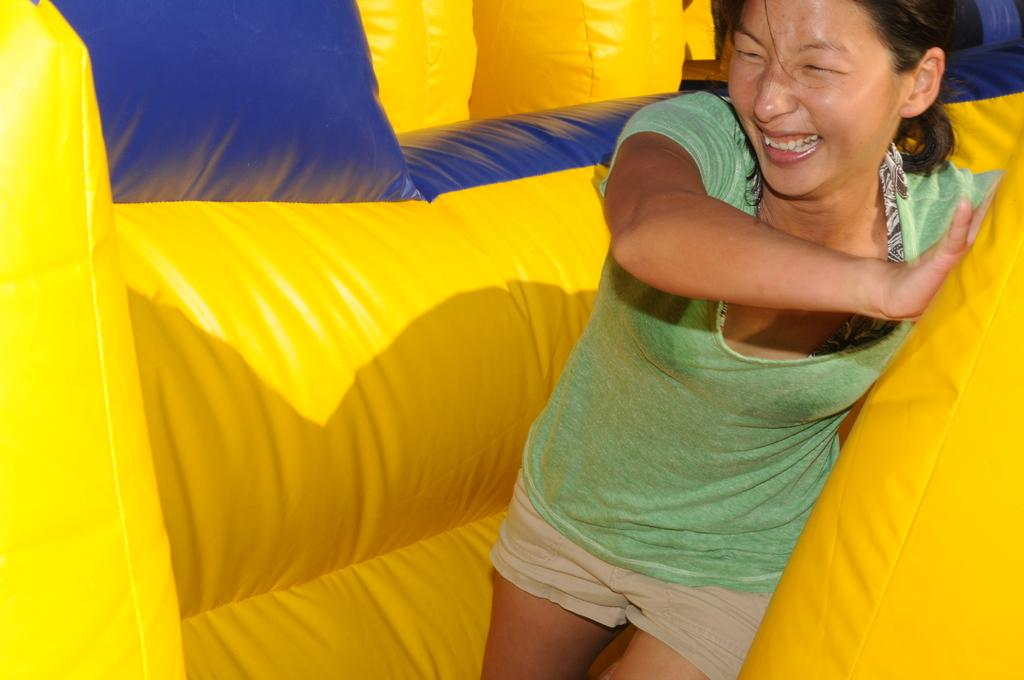Who is present in the image? There is a lady in the image. What is the lady doing in the image? The lady is in an air balloon. On which side of the image is the air balloon located? The air balloon is on the right side of the image. How many trees can be seen in the image? There are no trees visible in the image; it only features a lady in an air balloon. Is the lady riding a bike in the image? No, the lady is not riding a bike in the image; she is in an air balloon. 